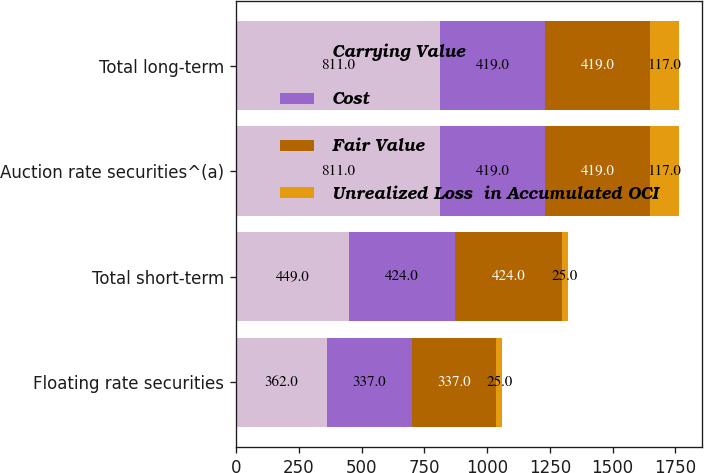<chart> <loc_0><loc_0><loc_500><loc_500><stacked_bar_chart><ecel><fcel>Floating rate securities<fcel>Total short-term<fcel>Auction rate securities^(a)<fcel>Total long-term<nl><fcel>Carrying Value<fcel>362<fcel>449<fcel>811<fcel>811<nl><fcel>Cost<fcel>337<fcel>424<fcel>419<fcel>419<nl><fcel>Fair Value<fcel>337<fcel>424<fcel>419<fcel>419<nl><fcel>Unrealized Loss  in Accumulated OCI<fcel>25<fcel>25<fcel>117<fcel>117<nl></chart> 